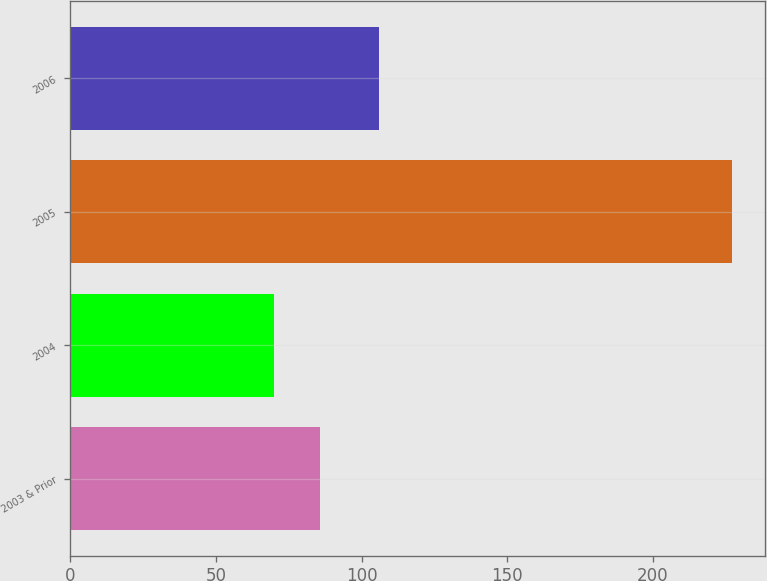Convert chart to OTSL. <chart><loc_0><loc_0><loc_500><loc_500><bar_chart><fcel>2003 & Prior<fcel>2004<fcel>2005<fcel>2006<nl><fcel>85.7<fcel>70<fcel>227<fcel>106<nl></chart> 